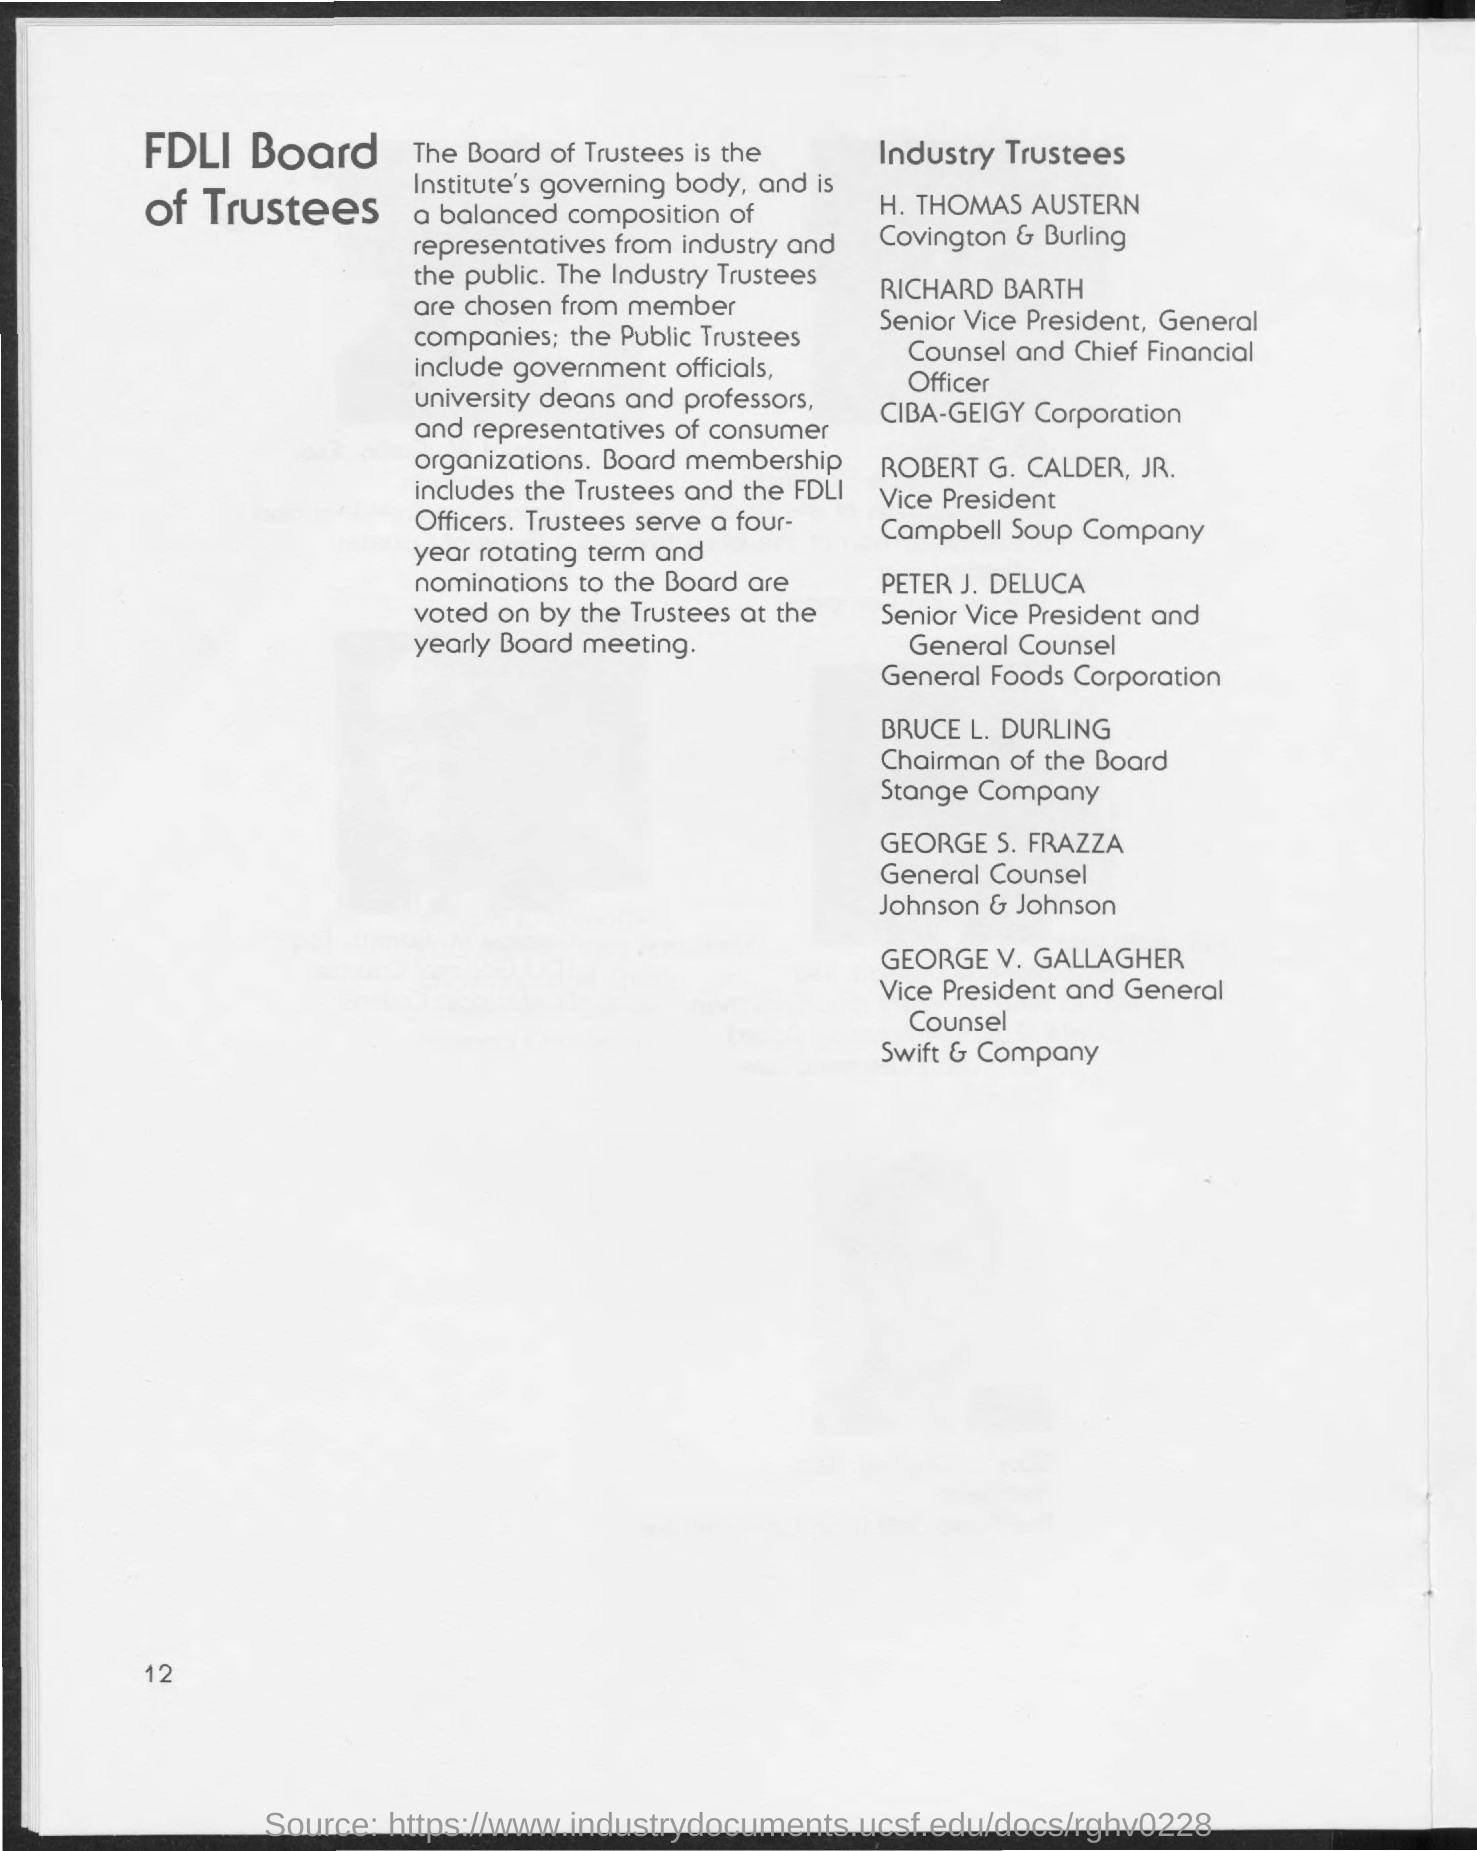The industry Trustees are chosen from where?
Offer a terse response. Member companies. Who does the Board Membership Include?
Offer a very short reply. The Trustees and the FDLI Officers. 